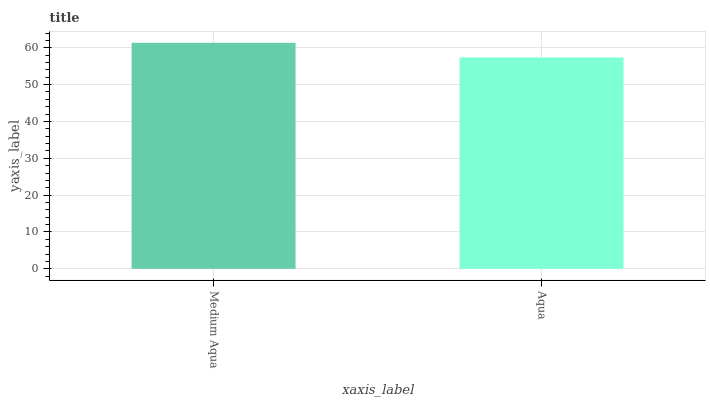Is Aqua the minimum?
Answer yes or no. Yes. Is Medium Aqua the maximum?
Answer yes or no. Yes. Is Aqua the maximum?
Answer yes or no. No. Is Medium Aqua greater than Aqua?
Answer yes or no. Yes. Is Aqua less than Medium Aqua?
Answer yes or no. Yes. Is Aqua greater than Medium Aqua?
Answer yes or no. No. Is Medium Aqua less than Aqua?
Answer yes or no. No. Is Medium Aqua the high median?
Answer yes or no. Yes. Is Aqua the low median?
Answer yes or no. Yes. Is Aqua the high median?
Answer yes or no. No. Is Medium Aqua the low median?
Answer yes or no. No. 